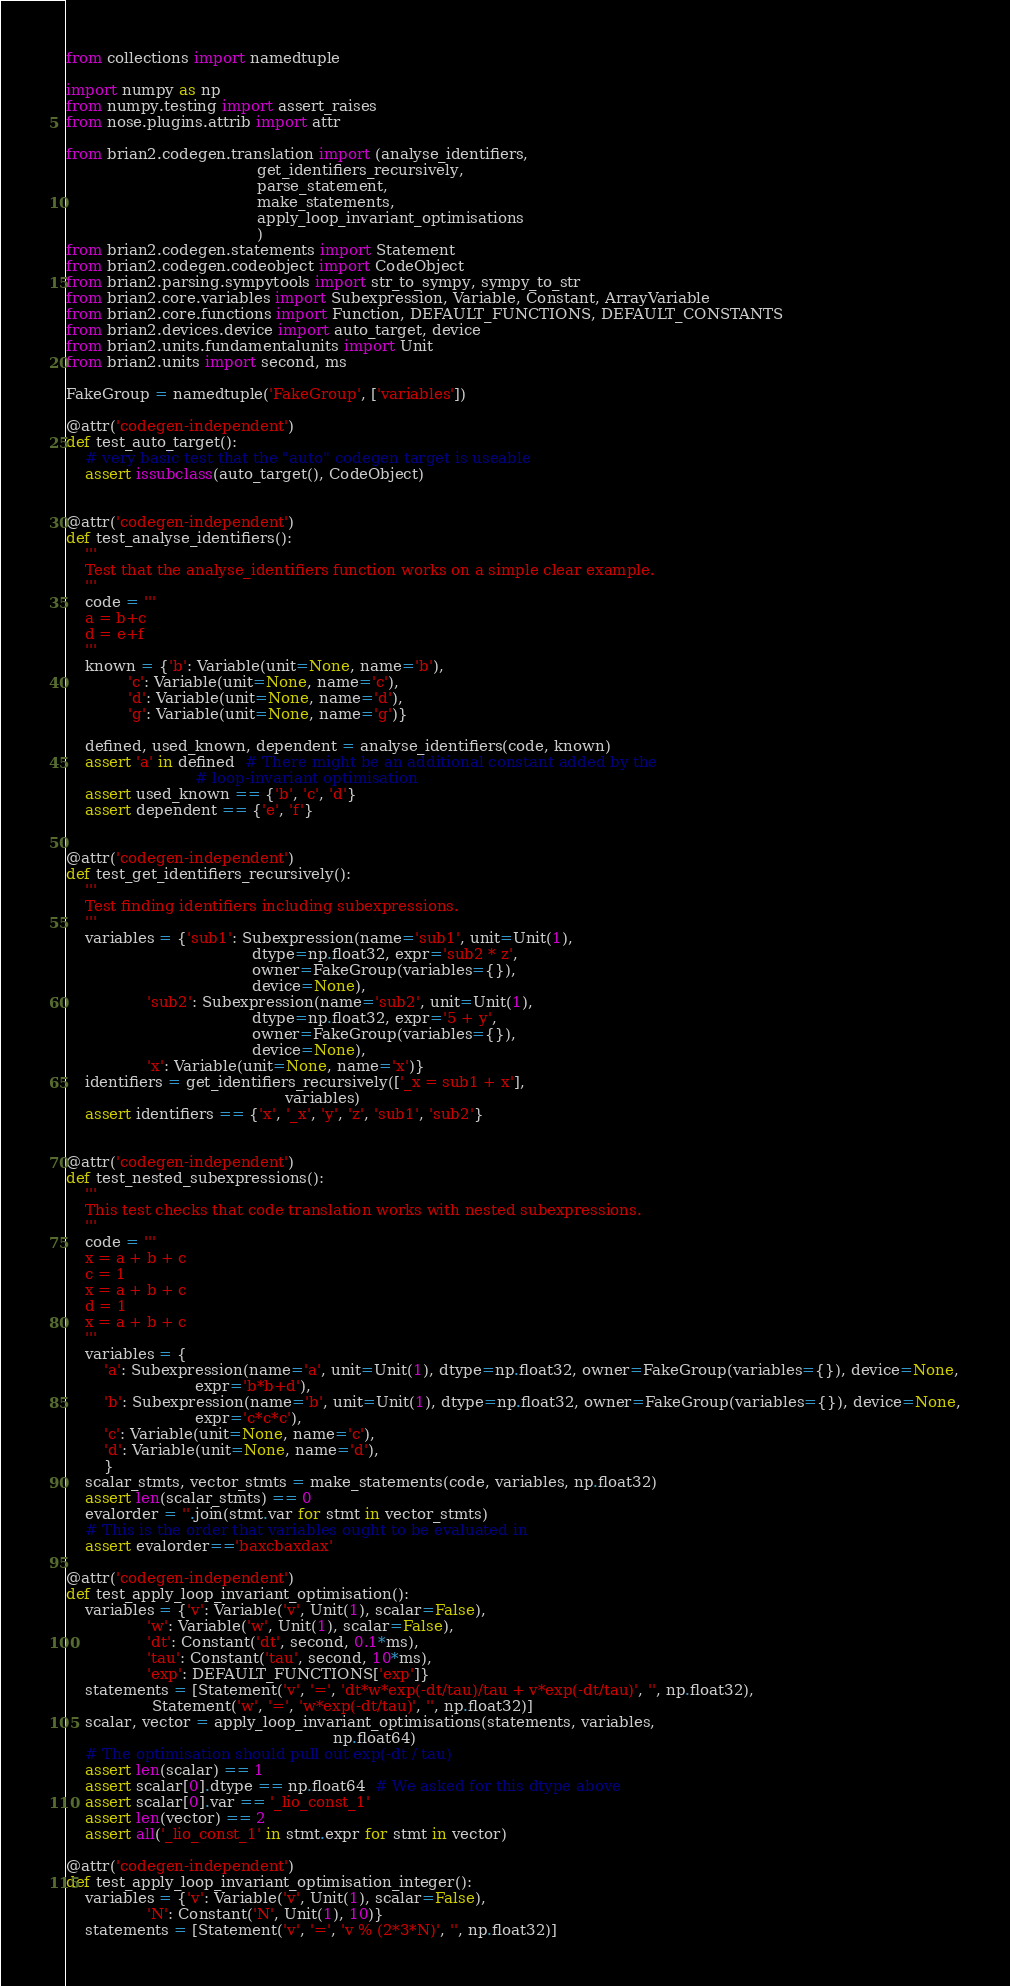Convert code to text. <code><loc_0><loc_0><loc_500><loc_500><_Python_>from collections import namedtuple

import numpy as np
from numpy.testing import assert_raises
from nose.plugins.attrib import attr

from brian2.codegen.translation import (analyse_identifiers,
                                        get_identifiers_recursively,
                                        parse_statement,
                                        make_statements,
                                        apply_loop_invariant_optimisations
                                        )
from brian2.codegen.statements import Statement
from brian2.codegen.codeobject import CodeObject
from brian2.parsing.sympytools import str_to_sympy, sympy_to_str
from brian2.core.variables import Subexpression, Variable, Constant, ArrayVariable
from brian2.core.functions import Function, DEFAULT_FUNCTIONS, DEFAULT_CONSTANTS
from brian2.devices.device import auto_target, device
from brian2.units.fundamentalunits import Unit
from brian2.units import second, ms

FakeGroup = namedtuple('FakeGroup', ['variables'])

@attr('codegen-independent')
def test_auto_target():
    # very basic test that the "auto" codegen target is useable
    assert issubclass(auto_target(), CodeObject)


@attr('codegen-independent')
def test_analyse_identifiers():
    '''
    Test that the analyse_identifiers function works on a simple clear example.
    '''
    code = '''
    a = b+c
    d = e+f
    '''
    known = {'b': Variable(unit=None, name='b'),
             'c': Variable(unit=None, name='c'),
             'd': Variable(unit=None, name='d'),
             'g': Variable(unit=None, name='g')}
    
    defined, used_known, dependent = analyse_identifiers(code, known)
    assert 'a' in defined  # There might be an additional constant added by the
                           # loop-invariant optimisation
    assert used_known == {'b', 'c', 'd'}
    assert dependent == {'e', 'f'}


@attr('codegen-independent')
def test_get_identifiers_recursively():
    '''
    Test finding identifiers including subexpressions.
    '''
    variables = {'sub1': Subexpression(name='sub1', unit=Unit(1),
                                       dtype=np.float32, expr='sub2 * z',
                                       owner=FakeGroup(variables={}),
                                       device=None),
                 'sub2': Subexpression(name='sub2', unit=Unit(1),
                                       dtype=np.float32, expr='5 + y',
                                       owner=FakeGroup(variables={}),
                                       device=None),
                 'x': Variable(unit=None, name='x')}
    identifiers = get_identifiers_recursively(['_x = sub1 + x'],
                                              variables)
    assert identifiers == {'x', '_x', 'y', 'z', 'sub1', 'sub2'}


@attr('codegen-independent')
def test_nested_subexpressions():
    '''
    This test checks that code translation works with nested subexpressions.
    '''
    code = '''
    x = a + b + c
    c = 1
    x = a + b + c
    d = 1
    x = a + b + c
    '''
    variables = {
        'a': Subexpression(name='a', unit=Unit(1), dtype=np.float32, owner=FakeGroup(variables={}), device=None,
                           expr='b*b+d'),
        'b': Subexpression(name='b', unit=Unit(1), dtype=np.float32, owner=FakeGroup(variables={}), device=None,
                           expr='c*c*c'),
        'c': Variable(unit=None, name='c'),
        'd': Variable(unit=None, name='d'),
        }
    scalar_stmts, vector_stmts = make_statements(code, variables, np.float32)
    assert len(scalar_stmts) == 0
    evalorder = ''.join(stmt.var for stmt in vector_stmts)
    # This is the order that variables ought to be evaluated in
    assert evalorder=='baxcbaxdax'

@attr('codegen-independent')
def test_apply_loop_invariant_optimisation():
    variables = {'v': Variable('v', Unit(1), scalar=False),
                 'w': Variable('w', Unit(1), scalar=False),
                 'dt': Constant('dt', second, 0.1*ms),
                 'tau': Constant('tau', second, 10*ms),
                 'exp': DEFAULT_FUNCTIONS['exp']}
    statements = [Statement('v', '=', 'dt*w*exp(-dt/tau)/tau + v*exp(-dt/tau)', '', np.float32),
                  Statement('w', '=', 'w*exp(-dt/tau)', '', np.float32)]
    scalar, vector = apply_loop_invariant_optimisations(statements, variables,
                                                        np.float64)
    # The optimisation should pull out exp(-dt / tau)
    assert len(scalar) == 1
    assert scalar[0].dtype == np.float64  # We asked for this dtype above
    assert scalar[0].var == '_lio_const_1'
    assert len(vector) == 2
    assert all('_lio_const_1' in stmt.expr for stmt in vector)

@attr('codegen-independent')
def test_apply_loop_invariant_optimisation_integer():
    variables = {'v': Variable('v', Unit(1), scalar=False),
                 'N': Constant('N', Unit(1), 10)}
    statements = [Statement('v', '=', 'v % (2*3*N)', '', np.float32)]</code> 